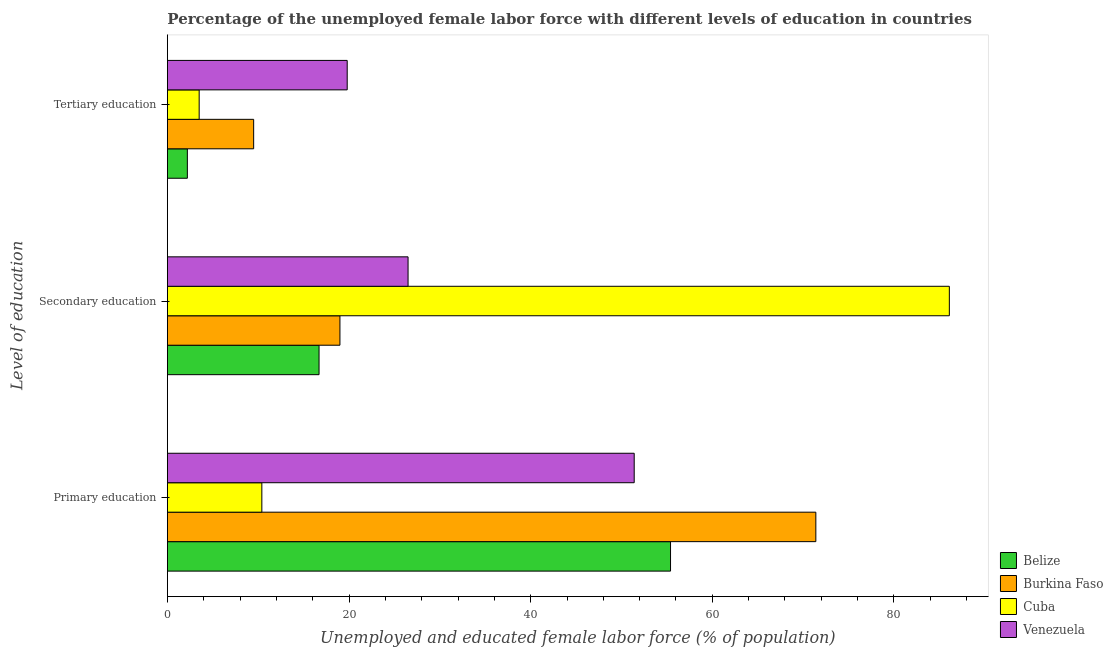How many groups of bars are there?
Provide a short and direct response. 3. Are the number of bars on each tick of the Y-axis equal?
Provide a succinct answer. Yes. What is the label of the 2nd group of bars from the top?
Your response must be concise. Secondary education. What is the percentage of female labor force who received tertiary education in Cuba?
Provide a short and direct response. 3.5. Across all countries, what is the maximum percentage of female labor force who received tertiary education?
Keep it short and to the point. 19.8. Across all countries, what is the minimum percentage of female labor force who received secondary education?
Give a very brief answer. 16.7. In which country was the percentage of female labor force who received secondary education maximum?
Offer a terse response. Cuba. In which country was the percentage of female labor force who received tertiary education minimum?
Offer a terse response. Belize. What is the total percentage of female labor force who received tertiary education in the graph?
Give a very brief answer. 35. What is the difference between the percentage of female labor force who received tertiary education in Venezuela and that in Burkina Faso?
Offer a terse response. 10.3. What is the difference between the percentage of female labor force who received primary education in Cuba and the percentage of female labor force who received tertiary education in Burkina Faso?
Offer a very short reply. 0.9. What is the average percentage of female labor force who received tertiary education per country?
Offer a very short reply. 8.75. What is the difference between the percentage of female labor force who received secondary education and percentage of female labor force who received tertiary education in Cuba?
Give a very brief answer. 82.6. What is the ratio of the percentage of female labor force who received primary education in Burkina Faso to that in Cuba?
Your answer should be compact. 6.87. Is the percentage of female labor force who received tertiary education in Cuba less than that in Belize?
Give a very brief answer. No. Is the difference between the percentage of female labor force who received tertiary education in Cuba and Venezuela greater than the difference between the percentage of female labor force who received primary education in Cuba and Venezuela?
Offer a terse response. Yes. What is the difference between the highest and the second highest percentage of female labor force who received primary education?
Offer a terse response. 16. What is the difference between the highest and the lowest percentage of female labor force who received secondary education?
Your answer should be very brief. 69.4. In how many countries, is the percentage of female labor force who received secondary education greater than the average percentage of female labor force who received secondary education taken over all countries?
Your response must be concise. 1. What does the 3rd bar from the top in Primary education represents?
Offer a terse response. Burkina Faso. What does the 1st bar from the bottom in Primary education represents?
Provide a succinct answer. Belize. Is it the case that in every country, the sum of the percentage of female labor force who received primary education and percentage of female labor force who received secondary education is greater than the percentage of female labor force who received tertiary education?
Give a very brief answer. Yes. How many bars are there?
Provide a succinct answer. 12. Are all the bars in the graph horizontal?
Give a very brief answer. Yes. How many countries are there in the graph?
Make the answer very short. 4. What is the difference between two consecutive major ticks on the X-axis?
Make the answer very short. 20. Are the values on the major ticks of X-axis written in scientific E-notation?
Provide a succinct answer. No. Does the graph contain grids?
Your response must be concise. No. How many legend labels are there?
Your response must be concise. 4. What is the title of the graph?
Provide a short and direct response. Percentage of the unemployed female labor force with different levels of education in countries. Does "Somalia" appear as one of the legend labels in the graph?
Offer a terse response. No. What is the label or title of the X-axis?
Offer a very short reply. Unemployed and educated female labor force (% of population). What is the label or title of the Y-axis?
Make the answer very short. Level of education. What is the Unemployed and educated female labor force (% of population) in Belize in Primary education?
Offer a very short reply. 55.4. What is the Unemployed and educated female labor force (% of population) in Burkina Faso in Primary education?
Provide a short and direct response. 71.4. What is the Unemployed and educated female labor force (% of population) of Cuba in Primary education?
Provide a succinct answer. 10.4. What is the Unemployed and educated female labor force (% of population) of Venezuela in Primary education?
Ensure brevity in your answer.  51.4. What is the Unemployed and educated female labor force (% of population) in Belize in Secondary education?
Provide a succinct answer. 16.7. What is the Unemployed and educated female labor force (% of population) in Cuba in Secondary education?
Make the answer very short. 86.1. What is the Unemployed and educated female labor force (% of population) in Belize in Tertiary education?
Provide a short and direct response. 2.2. What is the Unemployed and educated female labor force (% of population) in Burkina Faso in Tertiary education?
Make the answer very short. 9.5. What is the Unemployed and educated female labor force (% of population) of Venezuela in Tertiary education?
Keep it short and to the point. 19.8. Across all Level of education, what is the maximum Unemployed and educated female labor force (% of population) in Belize?
Offer a very short reply. 55.4. Across all Level of education, what is the maximum Unemployed and educated female labor force (% of population) in Burkina Faso?
Your answer should be very brief. 71.4. Across all Level of education, what is the maximum Unemployed and educated female labor force (% of population) of Cuba?
Give a very brief answer. 86.1. Across all Level of education, what is the maximum Unemployed and educated female labor force (% of population) of Venezuela?
Give a very brief answer. 51.4. Across all Level of education, what is the minimum Unemployed and educated female labor force (% of population) of Belize?
Your answer should be compact. 2.2. Across all Level of education, what is the minimum Unemployed and educated female labor force (% of population) of Burkina Faso?
Offer a terse response. 9.5. Across all Level of education, what is the minimum Unemployed and educated female labor force (% of population) in Venezuela?
Your answer should be very brief. 19.8. What is the total Unemployed and educated female labor force (% of population) of Belize in the graph?
Offer a terse response. 74.3. What is the total Unemployed and educated female labor force (% of population) in Burkina Faso in the graph?
Provide a succinct answer. 99.9. What is the total Unemployed and educated female labor force (% of population) of Cuba in the graph?
Ensure brevity in your answer.  100. What is the total Unemployed and educated female labor force (% of population) in Venezuela in the graph?
Give a very brief answer. 97.7. What is the difference between the Unemployed and educated female labor force (% of population) of Belize in Primary education and that in Secondary education?
Make the answer very short. 38.7. What is the difference between the Unemployed and educated female labor force (% of population) of Burkina Faso in Primary education and that in Secondary education?
Your response must be concise. 52.4. What is the difference between the Unemployed and educated female labor force (% of population) in Cuba in Primary education and that in Secondary education?
Make the answer very short. -75.7. What is the difference between the Unemployed and educated female labor force (% of population) in Venezuela in Primary education and that in Secondary education?
Your answer should be compact. 24.9. What is the difference between the Unemployed and educated female labor force (% of population) in Belize in Primary education and that in Tertiary education?
Offer a terse response. 53.2. What is the difference between the Unemployed and educated female labor force (% of population) in Burkina Faso in Primary education and that in Tertiary education?
Your answer should be very brief. 61.9. What is the difference between the Unemployed and educated female labor force (% of population) in Venezuela in Primary education and that in Tertiary education?
Your answer should be very brief. 31.6. What is the difference between the Unemployed and educated female labor force (% of population) of Burkina Faso in Secondary education and that in Tertiary education?
Provide a succinct answer. 9.5. What is the difference between the Unemployed and educated female labor force (% of population) of Cuba in Secondary education and that in Tertiary education?
Make the answer very short. 82.6. What is the difference between the Unemployed and educated female labor force (% of population) of Belize in Primary education and the Unemployed and educated female labor force (% of population) of Burkina Faso in Secondary education?
Offer a very short reply. 36.4. What is the difference between the Unemployed and educated female labor force (% of population) in Belize in Primary education and the Unemployed and educated female labor force (% of population) in Cuba in Secondary education?
Your response must be concise. -30.7. What is the difference between the Unemployed and educated female labor force (% of population) of Belize in Primary education and the Unemployed and educated female labor force (% of population) of Venezuela in Secondary education?
Your answer should be very brief. 28.9. What is the difference between the Unemployed and educated female labor force (% of population) in Burkina Faso in Primary education and the Unemployed and educated female labor force (% of population) in Cuba in Secondary education?
Provide a short and direct response. -14.7. What is the difference between the Unemployed and educated female labor force (% of population) of Burkina Faso in Primary education and the Unemployed and educated female labor force (% of population) of Venezuela in Secondary education?
Make the answer very short. 44.9. What is the difference between the Unemployed and educated female labor force (% of population) of Cuba in Primary education and the Unemployed and educated female labor force (% of population) of Venezuela in Secondary education?
Make the answer very short. -16.1. What is the difference between the Unemployed and educated female labor force (% of population) in Belize in Primary education and the Unemployed and educated female labor force (% of population) in Burkina Faso in Tertiary education?
Give a very brief answer. 45.9. What is the difference between the Unemployed and educated female labor force (% of population) in Belize in Primary education and the Unemployed and educated female labor force (% of population) in Cuba in Tertiary education?
Keep it short and to the point. 51.9. What is the difference between the Unemployed and educated female labor force (% of population) in Belize in Primary education and the Unemployed and educated female labor force (% of population) in Venezuela in Tertiary education?
Ensure brevity in your answer.  35.6. What is the difference between the Unemployed and educated female labor force (% of population) of Burkina Faso in Primary education and the Unemployed and educated female labor force (% of population) of Cuba in Tertiary education?
Ensure brevity in your answer.  67.9. What is the difference between the Unemployed and educated female labor force (% of population) of Burkina Faso in Primary education and the Unemployed and educated female labor force (% of population) of Venezuela in Tertiary education?
Provide a succinct answer. 51.6. What is the difference between the Unemployed and educated female labor force (% of population) in Belize in Secondary education and the Unemployed and educated female labor force (% of population) in Burkina Faso in Tertiary education?
Your answer should be very brief. 7.2. What is the difference between the Unemployed and educated female labor force (% of population) of Burkina Faso in Secondary education and the Unemployed and educated female labor force (% of population) of Venezuela in Tertiary education?
Your response must be concise. -0.8. What is the difference between the Unemployed and educated female labor force (% of population) of Cuba in Secondary education and the Unemployed and educated female labor force (% of population) of Venezuela in Tertiary education?
Your response must be concise. 66.3. What is the average Unemployed and educated female labor force (% of population) of Belize per Level of education?
Keep it short and to the point. 24.77. What is the average Unemployed and educated female labor force (% of population) in Burkina Faso per Level of education?
Your answer should be very brief. 33.3. What is the average Unemployed and educated female labor force (% of population) in Cuba per Level of education?
Your answer should be compact. 33.33. What is the average Unemployed and educated female labor force (% of population) in Venezuela per Level of education?
Your answer should be very brief. 32.57. What is the difference between the Unemployed and educated female labor force (% of population) of Belize and Unemployed and educated female labor force (% of population) of Burkina Faso in Primary education?
Provide a succinct answer. -16. What is the difference between the Unemployed and educated female labor force (% of population) in Belize and Unemployed and educated female labor force (% of population) in Cuba in Primary education?
Your response must be concise. 45. What is the difference between the Unemployed and educated female labor force (% of population) of Burkina Faso and Unemployed and educated female labor force (% of population) of Cuba in Primary education?
Give a very brief answer. 61. What is the difference between the Unemployed and educated female labor force (% of population) of Burkina Faso and Unemployed and educated female labor force (% of population) of Venezuela in Primary education?
Offer a terse response. 20. What is the difference between the Unemployed and educated female labor force (% of population) of Cuba and Unemployed and educated female labor force (% of population) of Venezuela in Primary education?
Give a very brief answer. -41. What is the difference between the Unemployed and educated female labor force (% of population) in Belize and Unemployed and educated female labor force (% of population) in Burkina Faso in Secondary education?
Give a very brief answer. -2.3. What is the difference between the Unemployed and educated female labor force (% of population) in Belize and Unemployed and educated female labor force (% of population) in Cuba in Secondary education?
Offer a very short reply. -69.4. What is the difference between the Unemployed and educated female labor force (% of population) of Burkina Faso and Unemployed and educated female labor force (% of population) of Cuba in Secondary education?
Your response must be concise. -67.1. What is the difference between the Unemployed and educated female labor force (% of population) in Burkina Faso and Unemployed and educated female labor force (% of population) in Venezuela in Secondary education?
Your answer should be very brief. -7.5. What is the difference between the Unemployed and educated female labor force (% of population) of Cuba and Unemployed and educated female labor force (% of population) of Venezuela in Secondary education?
Keep it short and to the point. 59.6. What is the difference between the Unemployed and educated female labor force (% of population) of Belize and Unemployed and educated female labor force (% of population) of Venezuela in Tertiary education?
Provide a short and direct response. -17.6. What is the difference between the Unemployed and educated female labor force (% of population) of Burkina Faso and Unemployed and educated female labor force (% of population) of Venezuela in Tertiary education?
Provide a succinct answer. -10.3. What is the difference between the Unemployed and educated female labor force (% of population) of Cuba and Unemployed and educated female labor force (% of population) of Venezuela in Tertiary education?
Give a very brief answer. -16.3. What is the ratio of the Unemployed and educated female labor force (% of population) in Belize in Primary education to that in Secondary education?
Give a very brief answer. 3.32. What is the ratio of the Unemployed and educated female labor force (% of population) of Burkina Faso in Primary education to that in Secondary education?
Offer a very short reply. 3.76. What is the ratio of the Unemployed and educated female labor force (% of population) of Cuba in Primary education to that in Secondary education?
Your response must be concise. 0.12. What is the ratio of the Unemployed and educated female labor force (% of population) in Venezuela in Primary education to that in Secondary education?
Provide a short and direct response. 1.94. What is the ratio of the Unemployed and educated female labor force (% of population) in Belize in Primary education to that in Tertiary education?
Offer a very short reply. 25.18. What is the ratio of the Unemployed and educated female labor force (% of population) in Burkina Faso in Primary education to that in Tertiary education?
Your response must be concise. 7.52. What is the ratio of the Unemployed and educated female labor force (% of population) in Cuba in Primary education to that in Tertiary education?
Offer a very short reply. 2.97. What is the ratio of the Unemployed and educated female labor force (% of population) in Venezuela in Primary education to that in Tertiary education?
Your answer should be very brief. 2.6. What is the ratio of the Unemployed and educated female labor force (% of population) in Belize in Secondary education to that in Tertiary education?
Offer a terse response. 7.59. What is the ratio of the Unemployed and educated female labor force (% of population) in Cuba in Secondary education to that in Tertiary education?
Your answer should be very brief. 24.6. What is the ratio of the Unemployed and educated female labor force (% of population) in Venezuela in Secondary education to that in Tertiary education?
Keep it short and to the point. 1.34. What is the difference between the highest and the second highest Unemployed and educated female labor force (% of population) of Belize?
Your answer should be compact. 38.7. What is the difference between the highest and the second highest Unemployed and educated female labor force (% of population) in Burkina Faso?
Your response must be concise. 52.4. What is the difference between the highest and the second highest Unemployed and educated female labor force (% of population) of Cuba?
Your response must be concise. 75.7. What is the difference between the highest and the second highest Unemployed and educated female labor force (% of population) in Venezuela?
Your answer should be very brief. 24.9. What is the difference between the highest and the lowest Unemployed and educated female labor force (% of population) of Belize?
Provide a short and direct response. 53.2. What is the difference between the highest and the lowest Unemployed and educated female labor force (% of population) of Burkina Faso?
Offer a terse response. 61.9. What is the difference between the highest and the lowest Unemployed and educated female labor force (% of population) of Cuba?
Make the answer very short. 82.6. What is the difference between the highest and the lowest Unemployed and educated female labor force (% of population) of Venezuela?
Keep it short and to the point. 31.6. 